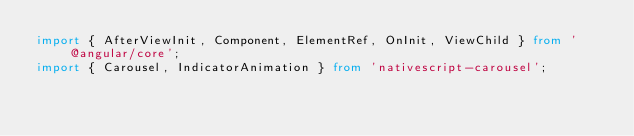Convert code to text. <code><loc_0><loc_0><loc_500><loc_500><_TypeScript_>import { AfterViewInit, Component, ElementRef, OnInit, ViewChild } from '@angular/core';
import { Carousel, IndicatorAnimation } from 'nativescript-carousel';</code> 